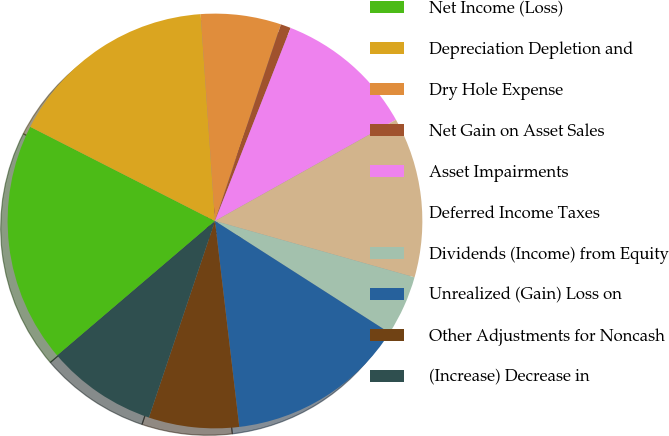Convert chart to OTSL. <chart><loc_0><loc_0><loc_500><loc_500><pie_chart><fcel>Net Income (Loss)<fcel>Depreciation Depletion and<fcel>Dry Hole Expense<fcel>Net Gain on Asset Sales<fcel>Asset Impairments<fcel>Deferred Income Taxes<fcel>Dividends (Income) from Equity<fcel>Unrealized (Gain) Loss on<fcel>Other Adjustments for Noncash<fcel>(Increase) Decrease in<nl><fcel>18.74%<fcel>16.4%<fcel>6.25%<fcel>0.79%<fcel>10.94%<fcel>12.5%<fcel>4.69%<fcel>14.06%<fcel>7.03%<fcel>8.6%<nl></chart> 